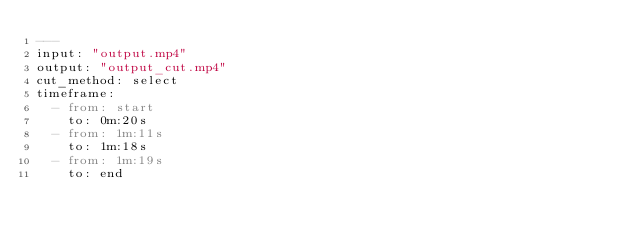Convert code to text. <code><loc_0><loc_0><loc_500><loc_500><_YAML_>---
input: "output.mp4"
output: "output_cut.mp4"
cut_method: select
timeframe:
  - from: start
    to: 0m:20s
  - from: 1m:11s
    to: 1m:18s 
  - from: 1m:19s
    to: end
</code> 